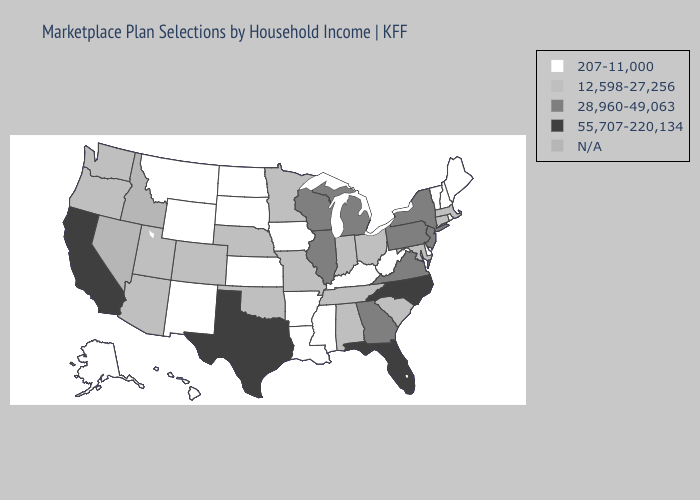Among the states that border South Carolina , which have the lowest value?
Be succinct. Georgia. Does Louisiana have the highest value in the South?
Short answer required. No. Among the states that border Illinois , does Wisconsin have the highest value?
Short answer required. Yes. What is the value of Arizona?
Keep it brief. 12,598-27,256. Does Michigan have the lowest value in the USA?
Be succinct. No. Does New York have the lowest value in the Northeast?
Quick response, please. No. Among the states that border Wyoming , does Utah have the lowest value?
Answer briefly. No. Does Tennessee have the highest value in the USA?
Short answer required. No. What is the highest value in states that border North Dakota?
Write a very short answer. 12,598-27,256. Name the states that have a value in the range N/A?
Quick response, please. Idaho, Nevada. Does Iowa have the lowest value in the MidWest?
Short answer required. Yes. What is the value of Nebraska?
Quick response, please. 12,598-27,256. How many symbols are there in the legend?
Concise answer only. 5. Which states have the lowest value in the MidWest?
Answer briefly. Iowa, Kansas, North Dakota, South Dakota. 